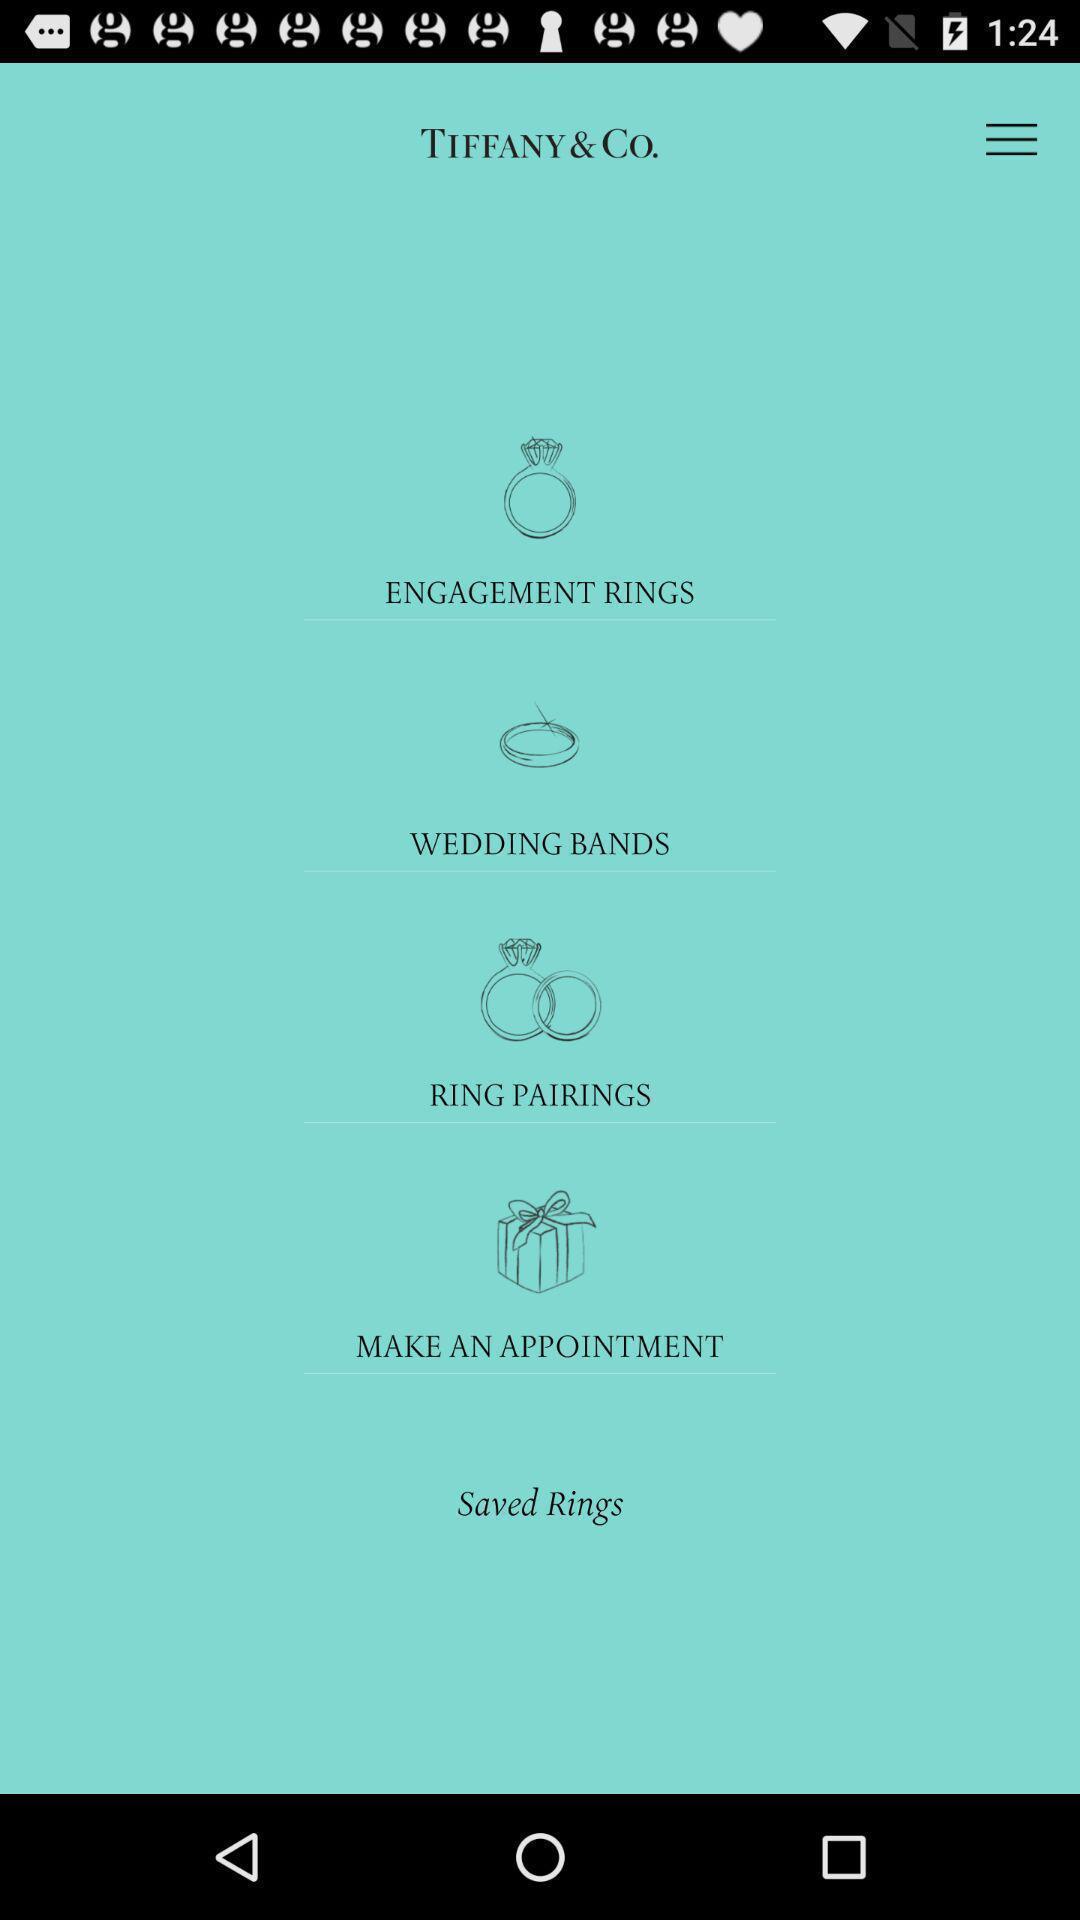Provide a detailed account of this screenshot. Screen displaying different kinds of rings. 